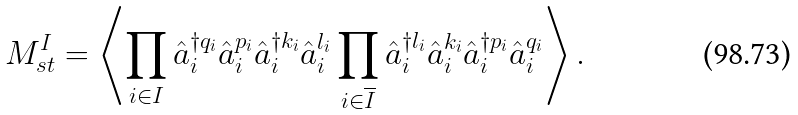Convert formula to latex. <formula><loc_0><loc_0><loc_500><loc_500>M ^ { I } _ { s t } = \left \langle \prod _ { i \in I } \hat { a } ^ { \dagger q _ { i } } _ { i } \hat { a } ^ { p _ { i } } _ { i } \hat { a } ^ { \dagger k _ { i } } _ { i } \hat { a } ^ { l _ { i } } _ { i } \prod _ { i \in \overline { I } } \hat { a } ^ { \dagger l _ { i } } _ { i } \hat { a } ^ { k _ { i } } _ { i } \hat { a } ^ { \dagger p _ { i } } _ { i } \hat { a } ^ { q _ { i } } _ { i } \right \rangle .</formula> 